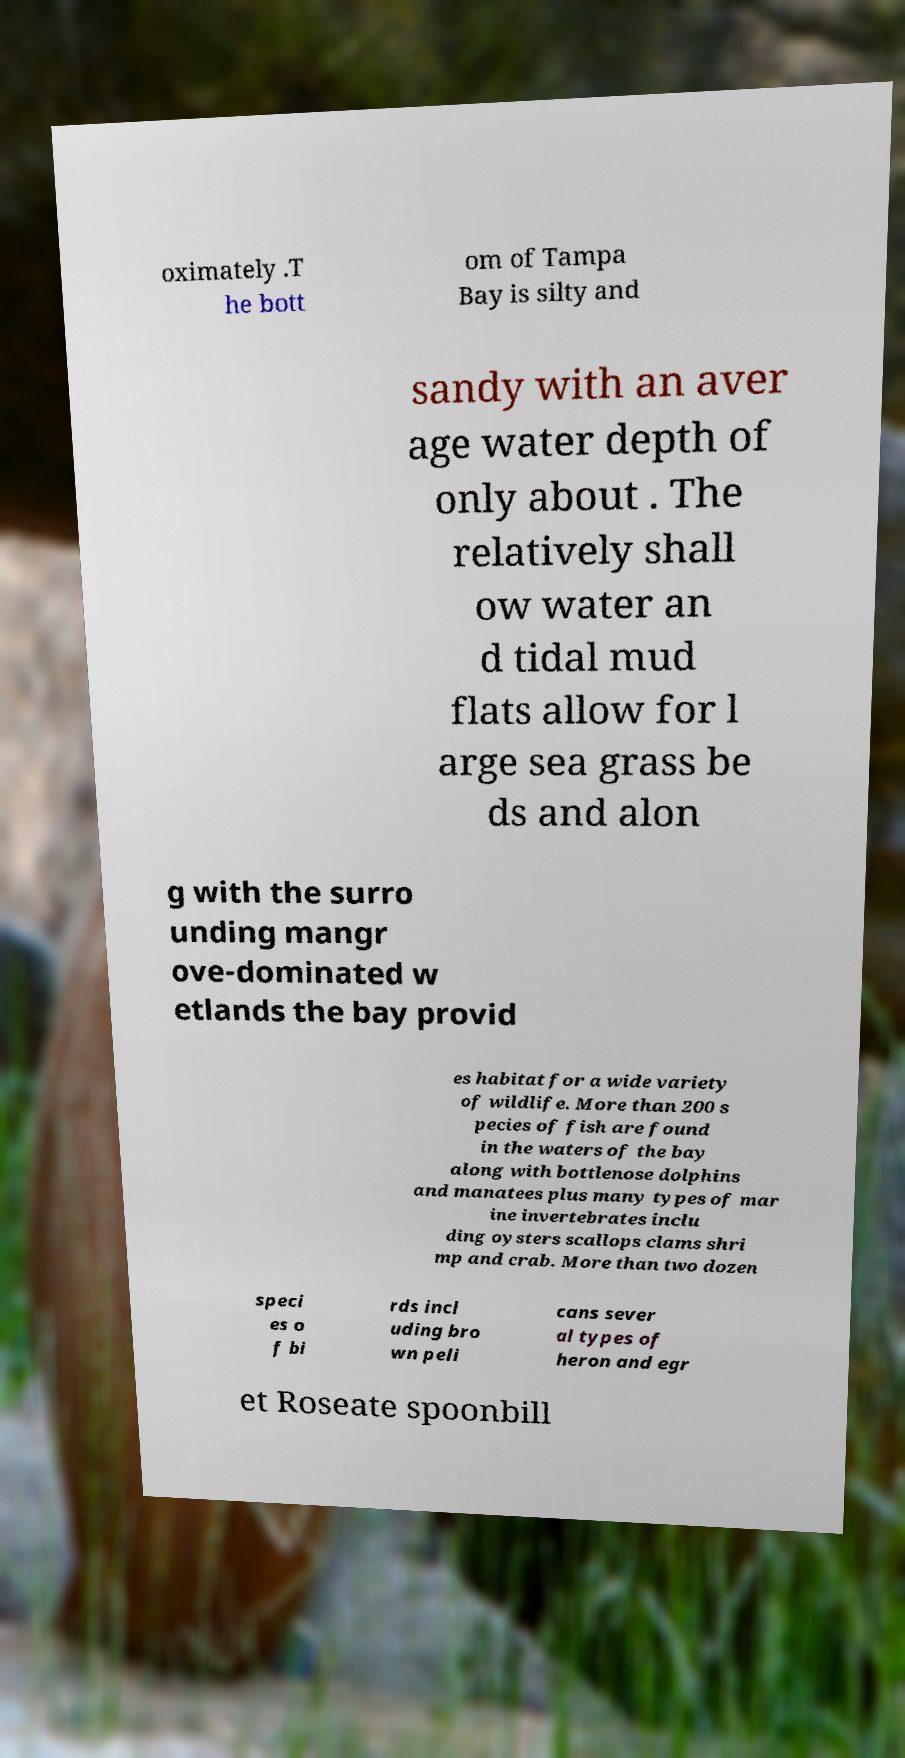I need the written content from this picture converted into text. Can you do that? oximately .T he bott om of Tampa Bay is silty and sandy with an aver age water depth of only about . The relatively shall ow water an d tidal mud flats allow for l arge sea grass be ds and alon g with the surro unding mangr ove-dominated w etlands the bay provid es habitat for a wide variety of wildlife. More than 200 s pecies of fish are found in the waters of the bay along with bottlenose dolphins and manatees plus many types of mar ine invertebrates inclu ding oysters scallops clams shri mp and crab. More than two dozen speci es o f bi rds incl uding bro wn peli cans sever al types of heron and egr et Roseate spoonbill 